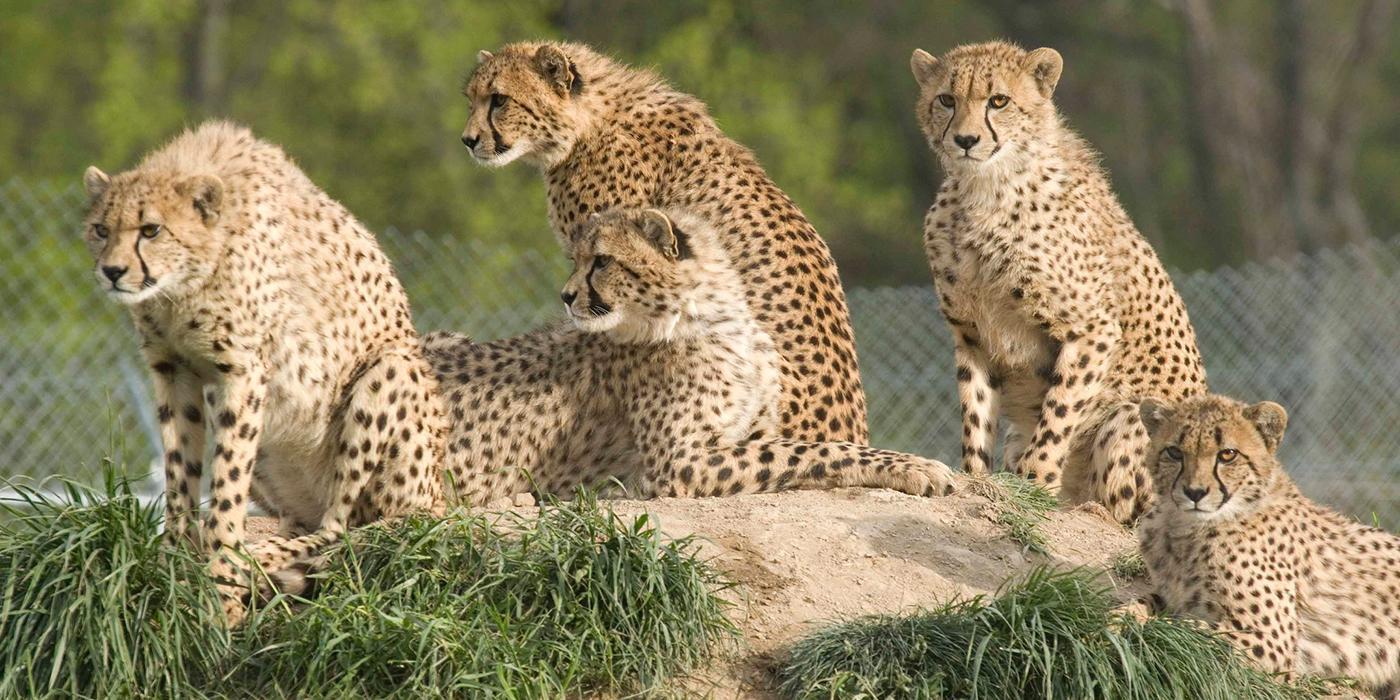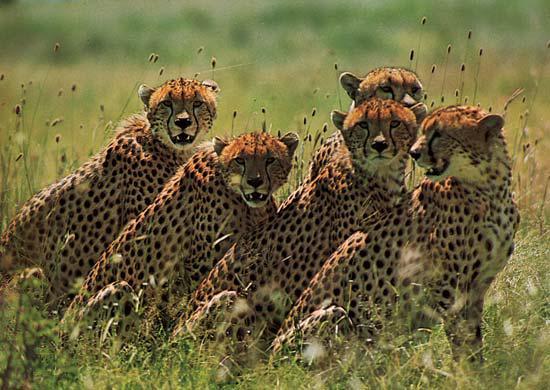The first image is the image on the left, the second image is the image on the right. For the images shown, is this caption "An image shows five cheetahs with their bodies similarly oriented, pointing right." true? Answer yes or no. Yes. 